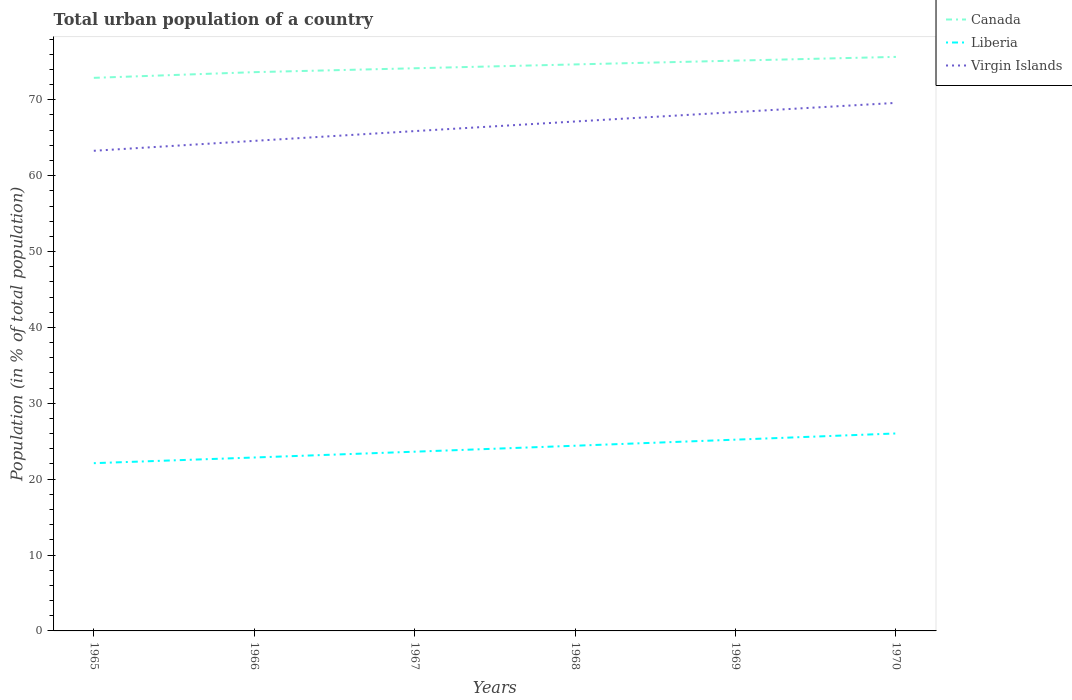Does the line corresponding to Liberia intersect with the line corresponding to Virgin Islands?
Your answer should be very brief. No. Is the number of lines equal to the number of legend labels?
Keep it short and to the point. Yes. Across all years, what is the maximum urban population in Virgin Islands?
Make the answer very short. 63.28. In which year was the urban population in Virgin Islands maximum?
Provide a short and direct response. 1965. What is the total urban population in Liberia in the graph?
Offer a terse response. -1.51. What is the difference between the highest and the second highest urban population in Liberia?
Provide a succinct answer. 3.92. What is the difference between the highest and the lowest urban population in Virgin Islands?
Provide a short and direct response. 3. How many lines are there?
Make the answer very short. 3. What is the difference between two consecutive major ticks on the Y-axis?
Make the answer very short. 10. Where does the legend appear in the graph?
Give a very brief answer. Top right. How are the legend labels stacked?
Your response must be concise. Vertical. What is the title of the graph?
Your answer should be compact. Total urban population of a country. What is the label or title of the X-axis?
Provide a succinct answer. Years. What is the label or title of the Y-axis?
Your answer should be compact. Population (in % of total population). What is the Population (in % of total population) of Canada in 1965?
Provide a succinct answer. 72.89. What is the Population (in % of total population) of Liberia in 1965?
Offer a very short reply. 22.11. What is the Population (in % of total population) of Virgin Islands in 1965?
Provide a succinct answer. 63.28. What is the Population (in % of total population) in Canada in 1966?
Provide a short and direct response. 73.64. What is the Population (in % of total population) of Liberia in 1966?
Provide a succinct answer. 22.86. What is the Population (in % of total population) of Virgin Islands in 1966?
Provide a succinct answer. 64.59. What is the Population (in % of total population) in Canada in 1967?
Give a very brief answer. 74.16. What is the Population (in % of total population) in Liberia in 1967?
Offer a very short reply. 23.62. What is the Population (in % of total population) of Virgin Islands in 1967?
Your answer should be compact. 65.87. What is the Population (in % of total population) in Canada in 1968?
Offer a terse response. 74.66. What is the Population (in % of total population) in Liberia in 1968?
Ensure brevity in your answer.  24.41. What is the Population (in % of total population) of Virgin Islands in 1968?
Offer a terse response. 67.14. What is the Population (in % of total population) in Canada in 1969?
Your answer should be very brief. 75.16. What is the Population (in % of total population) in Liberia in 1969?
Your response must be concise. 25.21. What is the Population (in % of total population) in Virgin Islands in 1969?
Your answer should be very brief. 68.38. What is the Population (in % of total population) in Canada in 1970?
Give a very brief answer. 75.65. What is the Population (in % of total population) in Liberia in 1970?
Keep it short and to the point. 26.02. What is the Population (in % of total population) of Virgin Islands in 1970?
Give a very brief answer. 69.59. Across all years, what is the maximum Population (in % of total population) in Canada?
Give a very brief answer. 75.65. Across all years, what is the maximum Population (in % of total population) of Liberia?
Provide a succinct answer. 26.02. Across all years, what is the maximum Population (in % of total population) of Virgin Islands?
Make the answer very short. 69.59. Across all years, what is the minimum Population (in % of total population) of Canada?
Provide a succinct answer. 72.89. Across all years, what is the minimum Population (in % of total population) of Liberia?
Your answer should be very brief. 22.11. Across all years, what is the minimum Population (in % of total population) in Virgin Islands?
Ensure brevity in your answer.  63.28. What is the total Population (in % of total population) of Canada in the graph?
Provide a short and direct response. 446.17. What is the total Population (in % of total population) in Liberia in the graph?
Your answer should be very brief. 144.22. What is the total Population (in % of total population) in Virgin Islands in the graph?
Make the answer very short. 398.85. What is the difference between the Population (in % of total population) of Canada in 1965 and that in 1966?
Your response must be concise. -0.75. What is the difference between the Population (in % of total population) of Liberia in 1965 and that in 1966?
Your answer should be compact. -0.75. What is the difference between the Population (in % of total population) in Virgin Islands in 1965 and that in 1966?
Provide a short and direct response. -1.31. What is the difference between the Population (in % of total population) of Canada in 1965 and that in 1967?
Offer a very short reply. -1.26. What is the difference between the Population (in % of total population) in Liberia in 1965 and that in 1967?
Your response must be concise. -1.51. What is the difference between the Population (in % of total population) in Virgin Islands in 1965 and that in 1967?
Keep it short and to the point. -2.6. What is the difference between the Population (in % of total population) of Canada in 1965 and that in 1968?
Provide a succinct answer. -1.77. What is the difference between the Population (in % of total population) in Liberia in 1965 and that in 1968?
Provide a short and direct response. -2.3. What is the difference between the Population (in % of total population) in Virgin Islands in 1965 and that in 1968?
Your answer should be very brief. -3.86. What is the difference between the Population (in % of total population) of Canada in 1965 and that in 1969?
Your answer should be very brief. -2.27. What is the difference between the Population (in % of total population) of Liberia in 1965 and that in 1969?
Your response must be concise. -3.1. What is the difference between the Population (in % of total population) in Virgin Islands in 1965 and that in 1969?
Make the answer very short. -5.1. What is the difference between the Population (in % of total population) of Canada in 1965 and that in 1970?
Ensure brevity in your answer.  -2.76. What is the difference between the Population (in % of total population) in Liberia in 1965 and that in 1970?
Your response must be concise. -3.92. What is the difference between the Population (in % of total population) in Virgin Islands in 1965 and that in 1970?
Make the answer very short. -6.31. What is the difference between the Population (in % of total population) of Canada in 1966 and that in 1967?
Provide a short and direct response. -0.51. What is the difference between the Population (in % of total population) in Liberia in 1966 and that in 1967?
Keep it short and to the point. -0.77. What is the difference between the Population (in % of total population) in Virgin Islands in 1966 and that in 1967?
Your response must be concise. -1.29. What is the difference between the Population (in % of total population) of Canada in 1966 and that in 1968?
Keep it short and to the point. -1.02. What is the difference between the Population (in % of total population) in Liberia in 1966 and that in 1968?
Provide a succinct answer. -1.55. What is the difference between the Population (in % of total population) of Virgin Islands in 1966 and that in 1968?
Give a very brief answer. -2.55. What is the difference between the Population (in % of total population) of Canada in 1966 and that in 1969?
Offer a very short reply. -1.52. What is the difference between the Population (in % of total population) of Liberia in 1966 and that in 1969?
Keep it short and to the point. -2.35. What is the difference between the Population (in % of total population) of Virgin Islands in 1966 and that in 1969?
Keep it short and to the point. -3.79. What is the difference between the Population (in % of total population) of Canada in 1966 and that in 1970?
Provide a succinct answer. -2.01. What is the difference between the Population (in % of total population) in Liberia in 1966 and that in 1970?
Give a very brief answer. -3.17. What is the difference between the Population (in % of total population) of Virgin Islands in 1966 and that in 1970?
Your response must be concise. -5. What is the difference between the Population (in % of total population) in Canada in 1967 and that in 1968?
Offer a very short reply. -0.51. What is the difference between the Population (in % of total population) of Liberia in 1967 and that in 1968?
Your answer should be very brief. -0.79. What is the difference between the Population (in % of total population) of Virgin Islands in 1967 and that in 1968?
Your answer should be very brief. -1.27. What is the difference between the Population (in % of total population) of Canada in 1967 and that in 1969?
Give a very brief answer. -1.01. What is the difference between the Population (in % of total population) in Liberia in 1967 and that in 1969?
Ensure brevity in your answer.  -1.58. What is the difference between the Population (in % of total population) in Virgin Islands in 1967 and that in 1969?
Make the answer very short. -2.5. What is the difference between the Population (in % of total population) of Canada in 1967 and that in 1970?
Your answer should be very brief. -1.5. What is the difference between the Population (in % of total population) in Liberia in 1967 and that in 1970?
Make the answer very short. -2.4. What is the difference between the Population (in % of total population) of Virgin Islands in 1967 and that in 1970?
Provide a succinct answer. -3.72. What is the difference between the Population (in % of total population) in Canada in 1968 and that in 1969?
Ensure brevity in your answer.  -0.5. What is the difference between the Population (in % of total population) in Virgin Islands in 1968 and that in 1969?
Provide a short and direct response. -1.24. What is the difference between the Population (in % of total population) of Canada in 1968 and that in 1970?
Ensure brevity in your answer.  -0.99. What is the difference between the Population (in % of total population) of Liberia in 1968 and that in 1970?
Your answer should be very brief. -1.62. What is the difference between the Population (in % of total population) in Virgin Islands in 1968 and that in 1970?
Provide a short and direct response. -2.45. What is the difference between the Population (in % of total population) of Canada in 1969 and that in 1970?
Provide a short and direct response. -0.49. What is the difference between the Population (in % of total population) of Liberia in 1969 and that in 1970?
Your response must be concise. -0.82. What is the difference between the Population (in % of total population) in Virgin Islands in 1969 and that in 1970?
Your answer should be compact. -1.21. What is the difference between the Population (in % of total population) in Canada in 1965 and the Population (in % of total population) in Liberia in 1966?
Give a very brief answer. 50.04. What is the difference between the Population (in % of total population) of Canada in 1965 and the Population (in % of total population) of Virgin Islands in 1966?
Your answer should be very brief. 8.3. What is the difference between the Population (in % of total population) in Liberia in 1965 and the Population (in % of total population) in Virgin Islands in 1966?
Offer a very short reply. -42.48. What is the difference between the Population (in % of total population) in Canada in 1965 and the Population (in % of total population) in Liberia in 1967?
Offer a terse response. 49.27. What is the difference between the Population (in % of total population) of Canada in 1965 and the Population (in % of total population) of Virgin Islands in 1967?
Keep it short and to the point. 7.02. What is the difference between the Population (in % of total population) of Liberia in 1965 and the Population (in % of total population) of Virgin Islands in 1967?
Your response must be concise. -43.77. What is the difference between the Population (in % of total population) in Canada in 1965 and the Population (in % of total population) in Liberia in 1968?
Provide a short and direct response. 48.48. What is the difference between the Population (in % of total population) of Canada in 1965 and the Population (in % of total population) of Virgin Islands in 1968?
Offer a terse response. 5.75. What is the difference between the Population (in % of total population) in Liberia in 1965 and the Population (in % of total population) in Virgin Islands in 1968?
Provide a short and direct response. -45.03. What is the difference between the Population (in % of total population) in Canada in 1965 and the Population (in % of total population) in Liberia in 1969?
Make the answer very short. 47.69. What is the difference between the Population (in % of total population) of Canada in 1965 and the Population (in % of total population) of Virgin Islands in 1969?
Keep it short and to the point. 4.51. What is the difference between the Population (in % of total population) in Liberia in 1965 and the Population (in % of total population) in Virgin Islands in 1969?
Provide a short and direct response. -46.27. What is the difference between the Population (in % of total population) in Canada in 1965 and the Population (in % of total population) in Liberia in 1970?
Keep it short and to the point. 46.87. What is the difference between the Population (in % of total population) in Canada in 1965 and the Population (in % of total population) in Virgin Islands in 1970?
Keep it short and to the point. 3.3. What is the difference between the Population (in % of total population) in Liberia in 1965 and the Population (in % of total population) in Virgin Islands in 1970?
Your answer should be compact. -47.48. What is the difference between the Population (in % of total population) of Canada in 1966 and the Population (in % of total population) of Liberia in 1967?
Give a very brief answer. 50.02. What is the difference between the Population (in % of total population) in Canada in 1966 and the Population (in % of total population) in Virgin Islands in 1967?
Your answer should be compact. 7.77. What is the difference between the Population (in % of total population) of Liberia in 1966 and the Population (in % of total population) of Virgin Islands in 1967?
Offer a very short reply. -43.02. What is the difference between the Population (in % of total population) in Canada in 1966 and the Population (in % of total population) in Liberia in 1968?
Provide a succinct answer. 49.23. What is the difference between the Population (in % of total population) in Canada in 1966 and the Population (in % of total population) in Virgin Islands in 1968?
Offer a terse response. 6.5. What is the difference between the Population (in % of total population) of Liberia in 1966 and the Population (in % of total population) of Virgin Islands in 1968?
Give a very brief answer. -44.28. What is the difference between the Population (in % of total population) in Canada in 1966 and the Population (in % of total population) in Liberia in 1969?
Make the answer very short. 48.44. What is the difference between the Population (in % of total population) of Canada in 1966 and the Population (in % of total population) of Virgin Islands in 1969?
Your answer should be compact. 5.26. What is the difference between the Population (in % of total population) of Liberia in 1966 and the Population (in % of total population) of Virgin Islands in 1969?
Keep it short and to the point. -45.52. What is the difference between the Population (in % of total population) of Canada in 1966 and the Population (in % of total population) of Liberia in 1970?
Offer a terse response. 47.62. What is the difference between the Population (in % of total population) of Canada in 1966 and the Population (in % of total population) of Virgin Islands in 1970?
Offer a terse response. 4.05. What is the difference between the Population (in % of total population) in Liberia in 1966 and the Population (in % of total population) in Virgin Islands in 1970?
Provide a succinct answer. -46.74. What is the difference between the Population (in % of total population) in Canada in 1967 and the Population (in % of total population) in Liberia in 1968?
Ensure brevity in your answer.  49.75. What is the difference between the Population (in % of total population) in Canada in 1967 and the Population (in % of total population) in Virgin Islands in 1968?
Give a very brief answer. 7.01. What is the difference between the Population (in % of total population) in Liberia in 1967 and the Population (in % of total population) in Virgin Islands in 1968?
Ensure brevity in your answer.  -43.52. What is the difference between the Population (in % of total population) of Canada in 1967 and the Population (in % of total population) of Liberia in 1969?
Your answer should be compact. 48.95. What is the difference between the Population (in % of total population) in Canada in 1967 and the Population (in % of total population) in Virgin Islands in 1969?
Ensure brevity in your answer.  5.78. What is the difference between the Population (in % of total population) in Liberia in 1967 and the Population (in % of total population) in Virgin Islands in 1969?
Keep it short and to the point. -44.76. What is the difference between the Population (in % of total population) in Canada in 1967 and the Population (in % of total population) in Liberia in 1970?
Provide a short and direct response. 48.13. What is the difference between the Population (in % of total population) in Canada in 1967 and the Population (in % of total population) in Virgin Islands in 1970?
Provide a succinct answer. 4.56. What is the difference between the Population (in % of total population) of Liberia in 1967 and the Population (in % of total population) of Virgin Islands in 1970?
Keep it short and to the point. -45.97. What is the difference between the Population (in % of total population) in Canada in 1968 and the Population (in % of total population) in Liberia in 1969?
Offer a terse response. 49.45. What is the difference between the Population (in % of total population) of Canada in 1968 and the Population (in % of total population) of Virgin Islands in 1969?
Provide a short and direct response. 6.28. What is the difference between the Population (in % of total population) of Liberia in 1968 and the Population (in % of total population) of Virgin Islands in 1969?
Make the answer very short. -43.97. What is the difference between the Population (in % of total population) of Canada in 1968 and the Population (in % of total population) of Liberia in 1970?
Keep it short and to the point. 48.64. What is the difference between the Population (in % of total population) of Canada in 1968 and the Population (in % of total population) of Virgin Islands in 1970?
Provide a succinct answer. 5.07. What is the difference between the Population (in % of total population) of Liberia in 1968 and the Population (in % of total population) of Virgin Islands in 1970?
Provide a succinct answer. -45.19. What is the difference between the Population (in % of total population) in Canada in 1969 and the Population (in % of total population) in Liberia in 1970?
Give a very brief answer. 49.14. What is the difference between the Population (in % of total population) in Canada in 1969 and the Population (in % of total population) in Virgin Islands in 1970?
Provide a succinct answer. 5.57. What is the difference between the Population (in % of total population) in Liberia in 1969 and the Population (in % of total population) in Virgin Islands in 1970?
Provide a succinct answer. -44.38. What is the average Population (in % of total population) of Canada per year?
Provide a succinct answer. 74.36. What is the average Population (in % of total population) of Liberia per year?
Your answer should be compact. 24.04. What is the average Population (in % of total population) in Virgin Islands per year?
Your answer should be very brief. 66.47. In the year 1965, what is the difference between the Population (in % of total population) in Canada and Population (in % of total population) in Liberia?
Keep it short and to the point. 50.78. In the year 1965, what is the difference between the Population (in % of total population) of Canada and Population (in % of total population) of Virgin Islands?
Keep it short and to the point. 9.61. In the year 1965, what is the difference between the Population (in % of total population) in Liberia and Population (in % of total population) in Virgin Islands?
Offer a very short reply. -41.17. In the year 1966, what is the difference between the Population (in % of total population) in Canada and Population (in % of total population) in Liberia?
Keep it short and to the point. 50.79. In the year 1966, what is the difference between the Population (in % of total population) of Canada and Population (in % of total population) of Virgin Islands?
Keep it short and to the point. 9.05. In the year 1966, what is the difference between the Population (in % of total population) of Liberia and Population (in % of total population) of Virgin Islands?
Ensure brevity in your answer.  -41.73. In the year 1967, what is the difference between the Population (in % of total population) in Canada and Population (in % of total population) in Liberia?
Provide a succinct answer. 50.53. In the year 1967, what is the difference between the Population (in % of total population) in Canada and Population (in % of total population) in Virgin Islands?
Offer a terse response. 8.28. In the year 1967, what is the difference between the Population (in % of total population) of Liberia and Population (in % of total population) of Virgin Islands?
Keep it short and to the point. -42.25. In the year 1968, what is the difference between the Population (in % of total population) in Canada and Population (in % of total population) in Liberia?
Your response must be concise. 50.26. In the year 1968, what is the difference between the Population (in % of total population) in Canada and Population (in % of total population) in Virgin Islands?
Provide a short and direct response. 7.52. In the year 1968, what is the difference between the Population (in % of total population) of Liberia and Population (in % of total population) of Virgin Islands?
Ensure brevity in your answer.  -42.73. In the year 1969, what is the difference between the Population (in % of total population) of Canada and Population (in % of total population) of Liberia?
Offer a very short reply. 49.95. In the year 1969, what is the difference between the Population (in % of total population) in Canada and Population (in % of total population) in Virgin Islands?
Your answer should be compact. 6.78. In the year 1969, what is the difference between the Population (in % of total population) of Liberia and Population (in % of total population) of Virgin Islands?
Keep it short and to the point. -43.17. In the year 1970, what is the difference between the Population (in % of total population) in Canada and Population (in % of total population) in Liberia?
Provide a short and direct response. 49.63. In the year 1970, what is the difference between the Population (in % of total population) of Canada and Population (in % of total population) of Virgin Islands?
Make the answer very short. 6.06. In the year 1970, what is the difference between the Population (in % of total population) of Liberia and Population (in % of total population) of Virgin Islands?
Make the answer very short. -43.57. What is the ratio of the Population (in % of total population) of Canada in 1965 to that in 1966?
Provide a short and direct response. 0.99. What is the ratio of the Population (in % of total population) of Liberia in 1965 to that in 1966?
Your answer should be very brief. 0.97. What is the ratio of the Population (in % of total population) of Virgin Islands in 1965 to that in 1966?
Offer a very short reply. 0.98. What is the ratio of the Population (in % of total population) in Canada in 1965 to that in 1967?
Your answer should be very brief. 0.98. What is the ratio of the Population (in % of total population) of Liberia in 1965 to that in 1967?
Your response must be concise. 0.94. What is the ratio of the Population (in % of total population) in Virgin Islands in 1965 to that in 1967?
Make the answer very short. 0.96. What is the ratio of the Population (in % of total population) of Canada in 1965 to that in 1968?
Give a very brief answer. 0.98. What is the ratio of the Population (in % of total population) in Liberia in 1965 to that in 1968?
Offer a terse response. 0.91. What is the ratio of the Population (in % of total population) of Virgin Islands in 1965 to that in 1968?
Provide a short and direct response. 0.94. What is the ratio of the Population (in % of total population) in Canada in 1965 to that in 1969?
Your answer should be compact. 0.97. What is the ratio of the Population (in % of total population) of Liberia in 1965 to that in 1969?
Give a very brief answer. 0.88. What is the ratio of the Population (in % of total population) of Virgin Islands in 1965 to that in 1969?
Offer a very short reply. 0.93. What is the ratio of the Population (in % of total population) of Canada in 1965 to that in 1970?
Keep it short and to the point. 0.96. What is the ratio of the Population (in % of total population) of Liberia in 1965 to that in 1970?
Your answer should be very brief. 0.85. What is the ratio of the Population (in % of total population) in Virgin Islands in 1965 to that in 1970?
Offer a very short reply. 0.91. What is the ratio of the Population (in % of total population) of Liberia in 1966 to that in 1967?
Keep it short and to the point. 0.97. What is the ratio of the Population (in % of total population) in Virgin Islands in 1966 to that in 1967?
Provide a short and direct response. 0.98. What is the ratio of the Population (in % of total population) in Canada in 1966 to that in 1968?
Your response must be concise. 0.99. What is the ratio of the Population (in % of total population) in Liberia in 1966 to that in 1968?
Make the answer very short. 0.94. What is the ratio of the Population (in % of total population) of Virgin Islands in 1966 to that in 1968?
Your response must be concise. 0.96. What is the ratio of the Population (in % of total population) in Canada in 1966 to that in 1969?
Ensure brevity in your answer.  0.98. What is the ratio of the Population (in % of total population) of Liberia in 1966 to that in 1969?
Your answer should be very brief. 0.91. What is the ratio of the Population (in % of total population) in Virgin Islands in 1966 to that in 1969?
Offer a terse response. 0.94. What is the ratio of the Population (in % of total population) in Canada in 1966 to that in 1970?
Offer a very short reply. 0.97. What is the ratio of the Population (in % of total population) of Liberia in 1966 to that in 1970?
Your response must be concise. 0.88. What is the ratio of the Population (in % of total population) in Virgin Islands in 1966 to that in 1970?
Make the answer very short. 0.93. What is the ratio of the Population (in % of total population) in Liberia in 1967 to that in 1968?
Ensure brevity in your answer.  0.97. What is the ratio of the Population (in % of total population) in Virgin Islands in 1967 to that in 1968?
Offer a terse response. 0.98. What is the ratio of the Population (in % of total population) in Canada in 1967 to that in 1969?
Your answer should be very brief. 0.99. What is the ratio of the Population (in % of total population) in Liberia in 1967 to that in 1969?
Provide a short and direct response. 0.94. What is the ratio of the Population (in % of total population) in Virgin Islands in 1967 to that in 1969?
Give a very brief answer. 0.96. What is the ratio of the Population (in % of total population) of Canada in 1967 to that in 1970?
Ensure brevity in your answer.  0.98. What is the ratio of the Population (in % of total population) in Liberia in 1967 to that in 1970?
Your answer should be compact. 0.91. What is the ratio of the Population (in % of total population) in Virgin Islands in 1967 to that in 1970?
Make the answer very short. 0.95. What is the ratio of the Population (in % of total population) in Canada in 1968 to that in 1969?
Ensure brevity in your answer.  0.99. What is the ratio of the Population (in % of total population) of Liberia in 1968 to that in 1969?
Ensure brevity in your answer.  0.97. What is the ratio of the Population (in % of total population) in Virgin Islands in 1968 to that in 1969?
Give a very brief answer. 0.98. What is the ratio of the Population (in % of total population) in Canada in 1968 to that in 1970?
Your response must be concise. 0.99. What is the ratio of the Population (in % of total population) of Liberia in 1968 to that in 1970?
Make the answer very short. 0.94. What is the ratio of the Population (in % of total population) of Virgin Islands in 1968 to that in 1970?
Offer a very short reply. 0.96. What is the ratio of the Population (in % of total population) of Canada in 1969 to that in 1970?
Your response must be concise. 0.99. What is the ratio of the Population (in % of total population) of Liberia in 1969 to that in 1970?
Provide a succinct answer. 0.97. What is the ratio of the Population (in % of total population) of Virgin Islands in 1969 to that in 1970?
Your response must be concise. 0.98. What is the difference between the highest and the second highest Population (in % of total population) of Canada?
Make the answer very short. 0.49. What is the difference between the highest and the second highest Population (in % of total population) of Liberia?
Your answer should be very brief. 0.82. What is the difference between the highest and the second highest Population (in % of total population) in Virgin Islands?
Your answer should be very brief. 1.21. What is the difference between the highest and the lowest Population (in % of total population) of Canada?
Offer a terse response. 2.76. What is the difference between the highest and the lowest Population (in % of total population) in Liberia?
Offer a very short reply. 3.92. What is the difference between the highest and the lowest Population (in % of total population) of Virgin Islands?
Offer a very short reply. 6.31. 